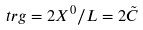Convert formula to latex. <formula><loc_0><loc_0><loc_500><loc_500>\ t r g = 2 X ^ { 0 } / L = 2 \tilde { C }</formula> 